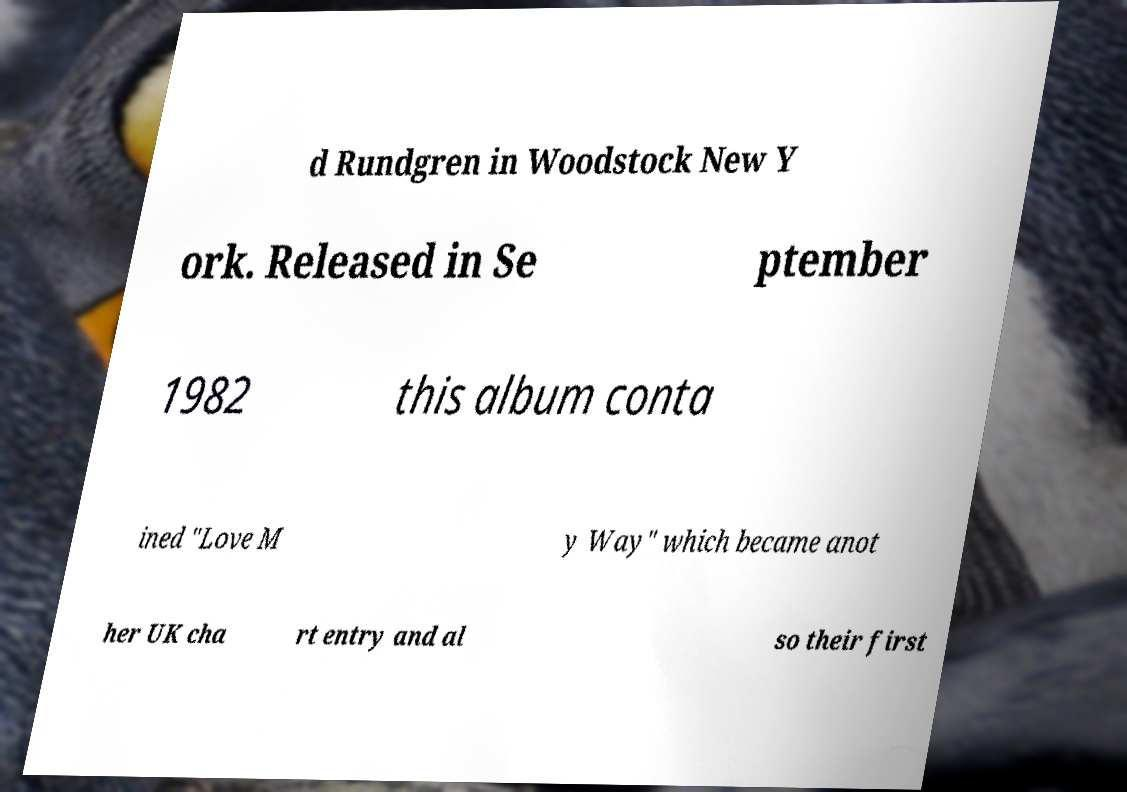Could you extract and type out the text from this image? d Rundgren in Woodstock New Y ork. Released in Se ptember 1982 this album conta ined "Love M y Way" which became anot her UK cha rt entry and al so their first 